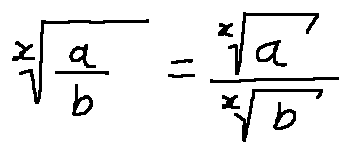Convert formula to latex. <formula><loc_0><loc_0><loc_500><loc_500>\sqrt { [ } x ] { \frac { a } { b } } = \frac { \sqrt { [ } x ] { a } } { \sqrt { [ } x ] { b } }</formula> 